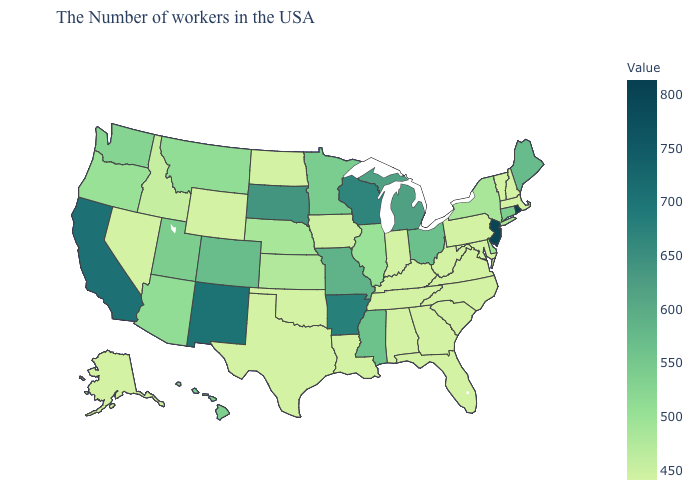Is the legend a continuous bar?
Concise answer only. Yes. Among the states that border Vermont , which have the lowest value?
Give a very brief answer. Massachusetts, New Hampshire. Does Montana have the highest value in the West?
Answer briefly. No. Which states have the highest value in the USA?
Quick response, please. Rhode Island. Is the legend a continuous bar?
Quick response, please. Yes. 